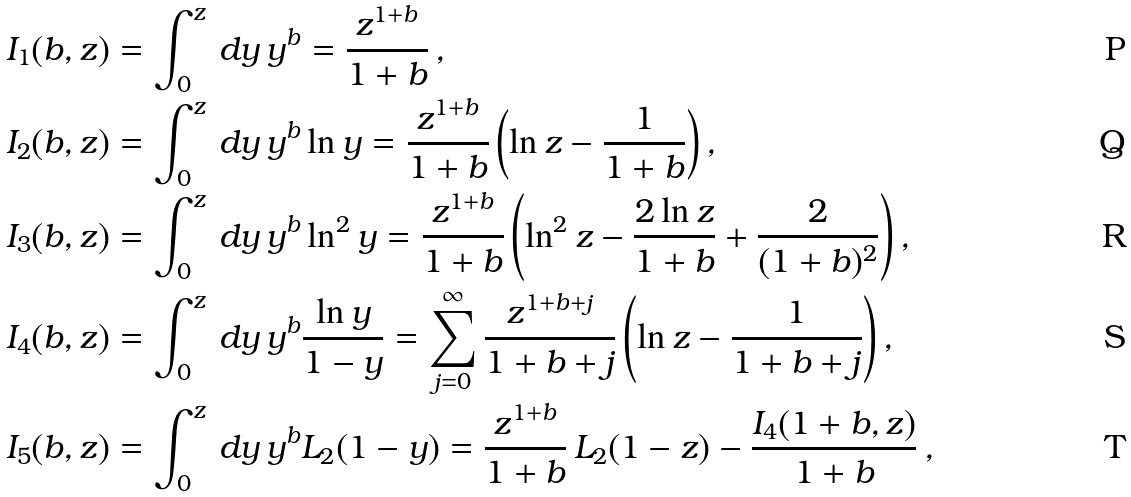Convert formula to latex. <formula><loc_0><loc_0><loc_500><loc_500>I _ { 1 } ( b , z ) & = \int _ { 0 } ^ { z } \, d y \, y ^ { b } = \frac { z ^ { 1 + b } } { 1 + b } \, , \\ I _ { 2 } ( b , z ) & = \int _ { 0 } ^ { z } \, d y \, y ^ { b } \ln y = \frac { z ^ { 1 + b } } { 1 + b } \left ( \ln z - \frac { 1 } { 1 + b } \right ) , \\ I _ { 3 } ( b , z ) & = \int _ { 0 } ^ { z } \, d y \, y ^ { b } \ln ^ { 2 } y = \frac { z ^ { 1 + b } } { 1 + b } \left ( \ln ^ { 2 } z - \frac { 2 \ln z } { 1 + b } + \frac { 2 } { ( 1 + b ) ^ { 2 } } \right ) , \\ I _ { 4 } ( b , z ) & = \int _ { 0 } ^ { z } \, d y \, y ^ { b } \frac { \ln y } { 1 - y } = \sum _ { j = 0 } ^ { \infty } \frac { z ^ { 1 + b + j } } { 1 + b + j } \left ( \ln z - \frac { 1 } { 1 + b + j } \right ) , \\ I _ { 5 } ( b , z ) & = \int _ { 0 } ^ { z } \, d y \, y ^ { b } L _ { 2 } ( 1 - y ) = \frac { z ^ { 1 + b } } { 1 + b } \, L _ { 2 } ( 1 - z ) - \frac { I _ { 4 } ( 1 + b , z ) } { 1 + b } \, ,</formula> 